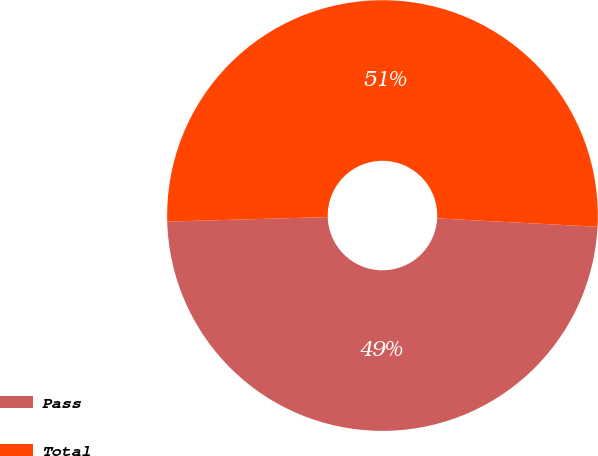Convert chart. <chart><loc_0><loc_0><loc_500><loc_500><pie_chart><fcel>Pass<fcel>Total<nl><fcel>48.72%<fcel>51.28%<nl></chart> 